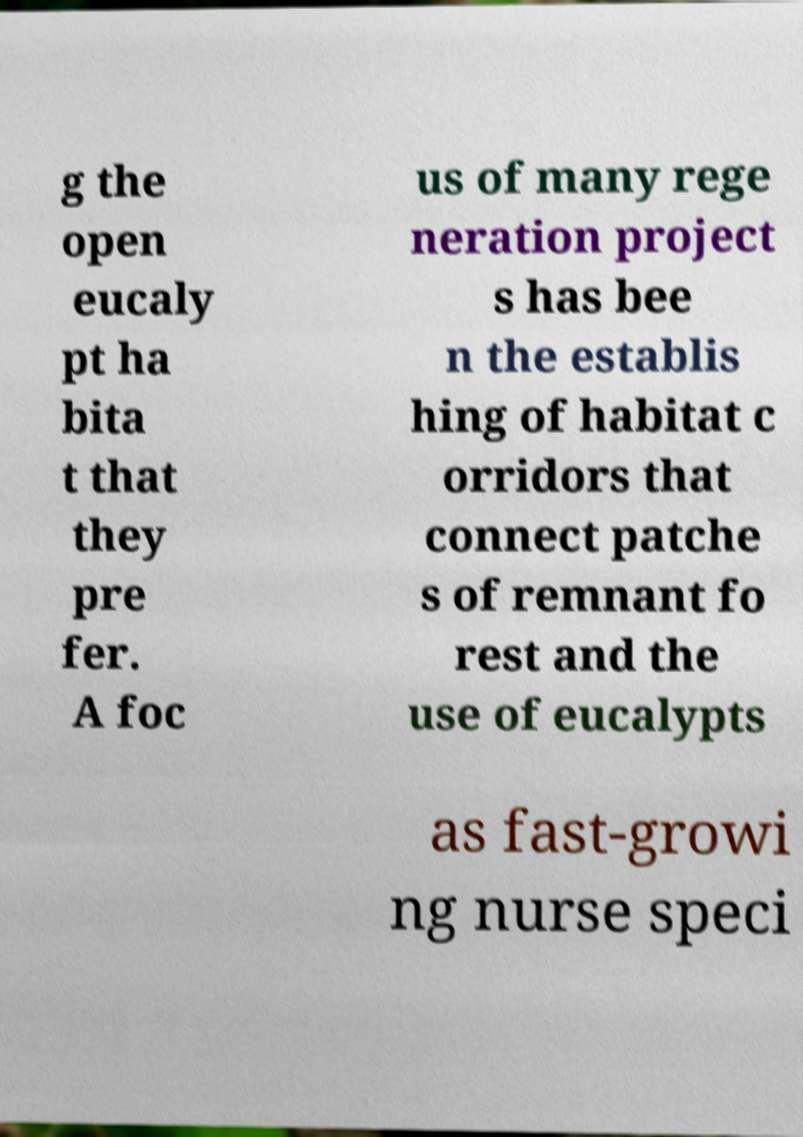What messages or text are displayed in this image? I need them in a readable, typed format. g the open eucaly pt ha bita t that they pre fer. A foc us of many rege neration project s has bee n the establis hing of habitat c orridors that connect patche s of remnant fo rest and the use of eucalypts as fast-growi ng nurse speci 